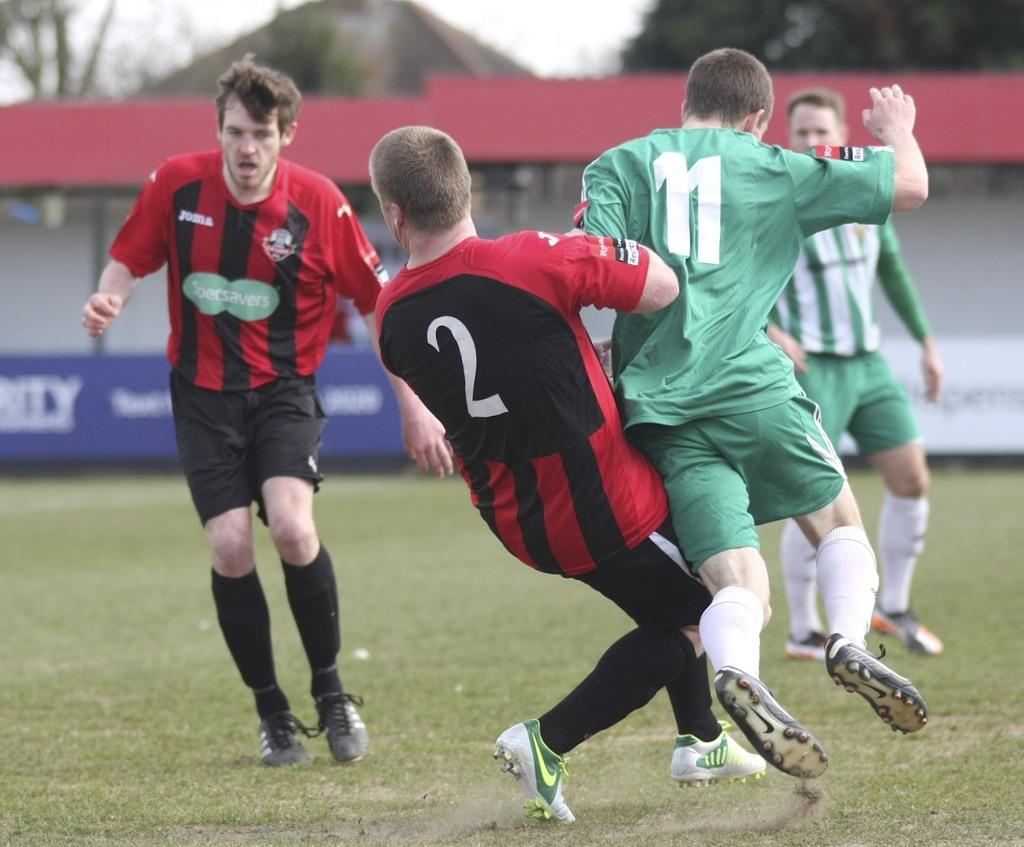What is happening with the group of people in the image? The group of people is on the ground. What can be seen in the background of the image? There are advertisement boards, a shed, a house, trees, and the sky visible in the background. Can you see any bees interacting with the skin of the people in the image? There are no bees or any interaction with the people's skin visible in the image. What type of tub is present in the image? There is no tub present in the image. 